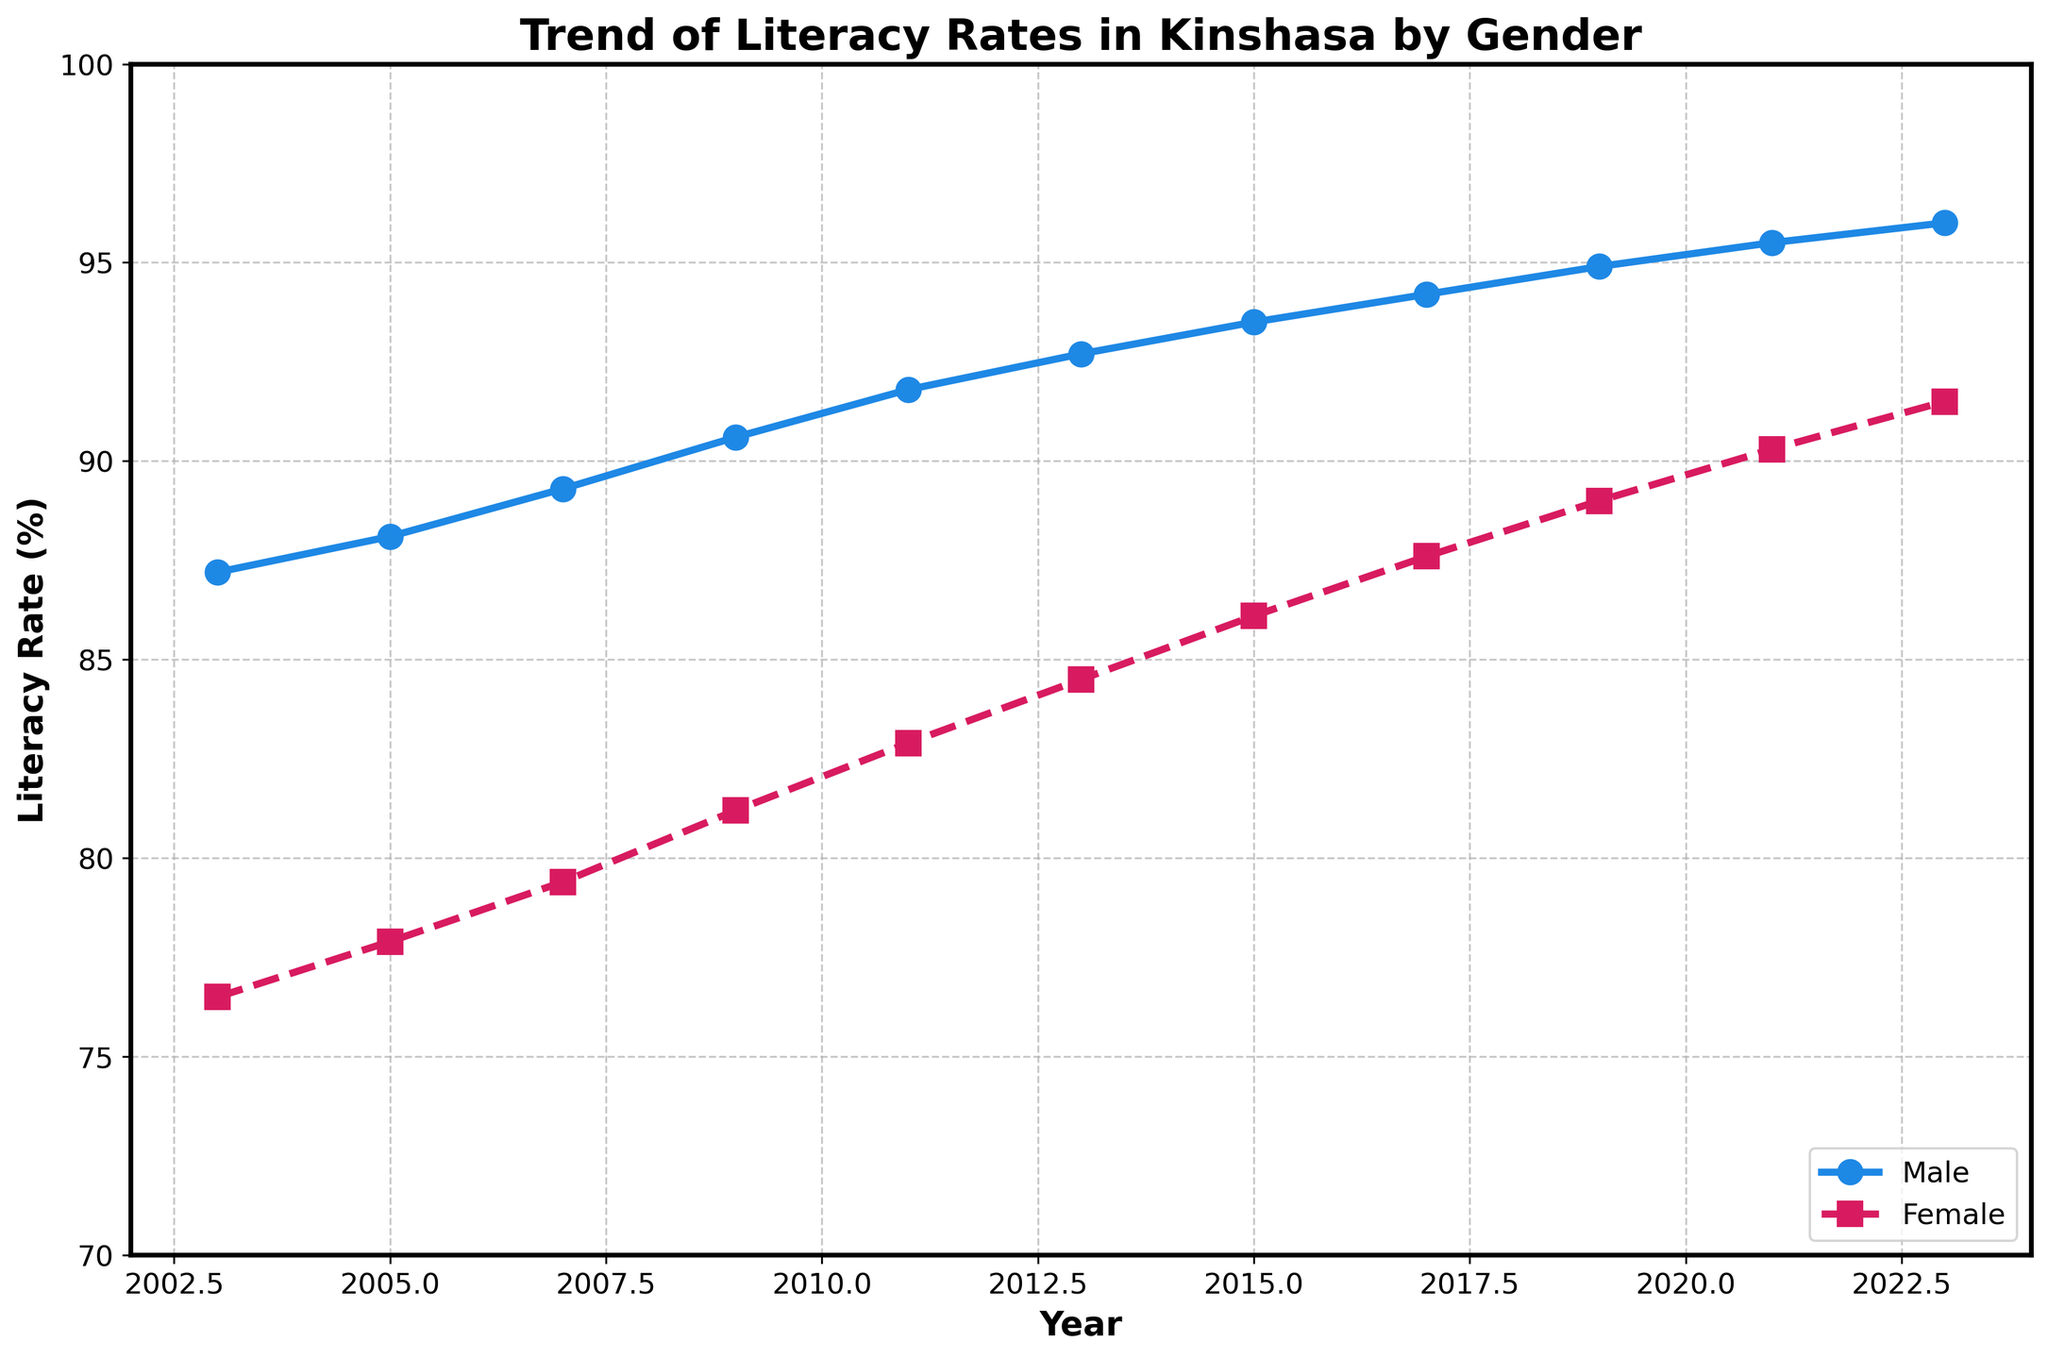What is the overall trend for male literacy rates from 2003 to 2023? The line representing male literacy rates shows a consistent increase from 87.2% in 2003 to 96.0% in 2023. This indicates an overall upward trend.
Answer: Upward trend What was the female literacy rate in 2013? By looking at the point representing the female literacy rate for the year 2013 on the line chart, it is approximately 84.5%.
Answer: 84.5% Which gender had a higher literacy rate in 2007 and by how much? In 2007, the male literacy rate was 89.3% while the female literacy rate was 79.4%. The difference is 89.3 - 79.4 = 9.9%.
Answer: Male by 9.9% Has the male literacy rate always been above 90% during the entire period? By inspecting the line representing male literacy rates, it crosses the 90% mark around 2010 and remains above this threshold thereafter but not before 2009.
Answer: No Between which years did the female literacy rate see the highest increment? Compare the increments for each two-year period. From 2009 to 2011, the female literacy rate increased from 81.2% to 82.9%, an increase of 1.7%, which is the largest increment between any consecutive two years.
Answer: 2009 to 2011 When did the female literacy rate first surpass 80%? By tracing the female literacy rate line, it first surpasses the 80% mark between 2007 and 2009, specifically in 2009 when it reaches 81.2%.
Answer: 2009 What was the average male literacy rate over the entire period? Add up all the male literacy rates and divide by the number of data points: (87.2 + 88.1 + 89.3 + 90.6 + 91.8 + 92.7 + 93.5 + 94.2 + 94.9 + 95.5 + 96.0) / 11 = 92.73%.
Answer: 92.73% How does the rate of increase in male literacy compare to the rate of increase in female literacy from 2003 to 2023? Male literacy increased from 87.2% to 96.0%, an increase of 8.8%. Female literacy increased from 76.5% to 91.5%, an increase of 15%. Thus, the rate of increase for females is higher.
Answer: Female rate of increase is higher Which literacy rate line has more markers and why? Both male and female literacy rate lines have the same number of markers because each has a marker for every data point from 2003 to 2023.
Answer: Same number 